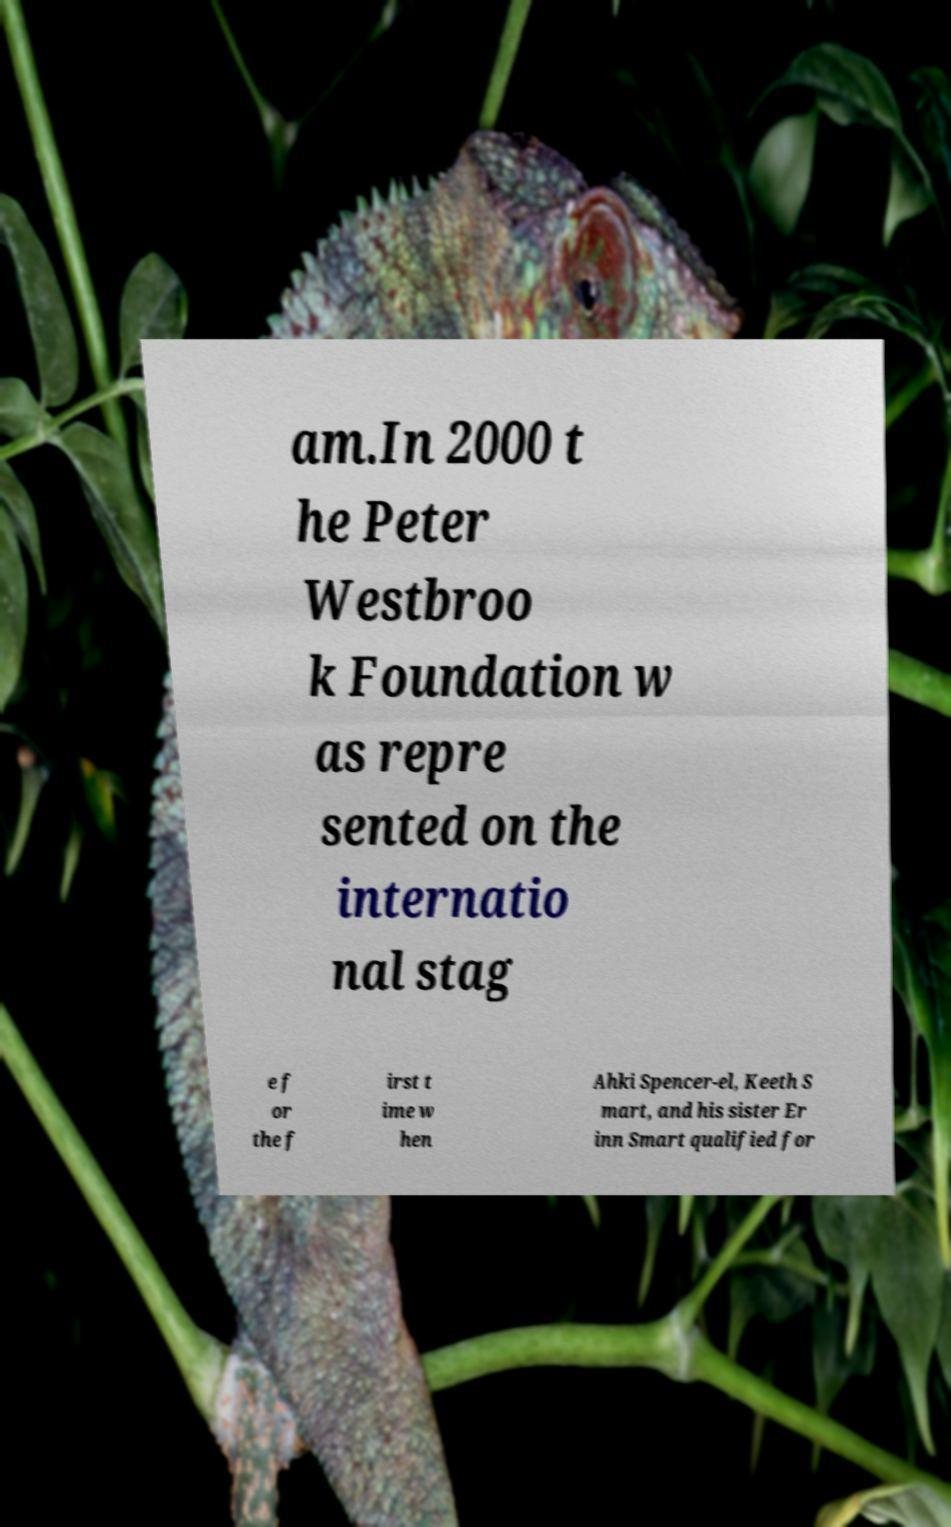Could you assist in decoding the text presented in this image and type it out clearly? am.In 2000 t he Peter Westbroo k Foundation w as repre sented on the internatio nal stag e f or the f irst t ime w hen Ahki Spencer-el, Keeth S mart, and his sister Er inn Smart qualified for 